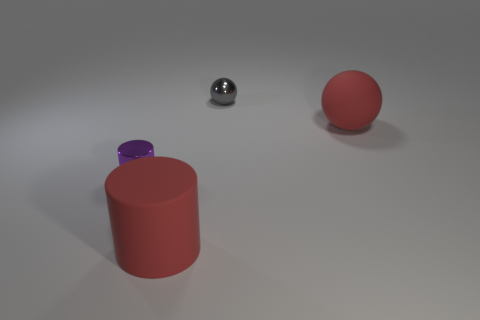What lighting conditions are indicated in the image? The image suggests a softly illuminated scene with diffused shadows, likely from an overhead light source. The smoothness of the objects' shadows confirms the diffuse nature of the lighting. 